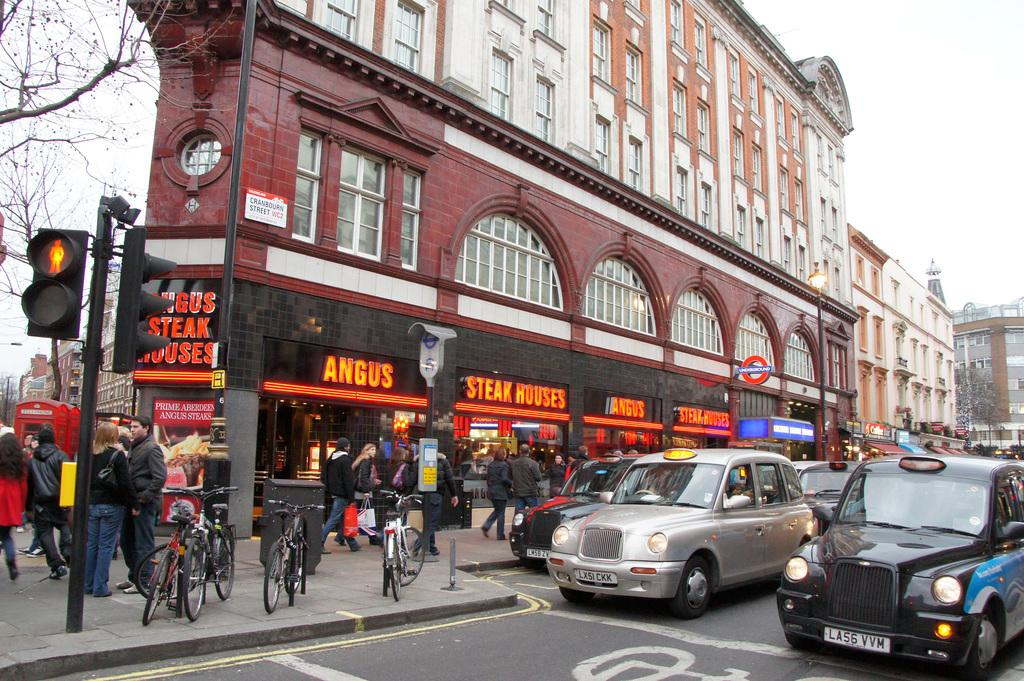<image>
Describe the image concisely. Angus Steak Houses is located next to a sign for the Underground. 